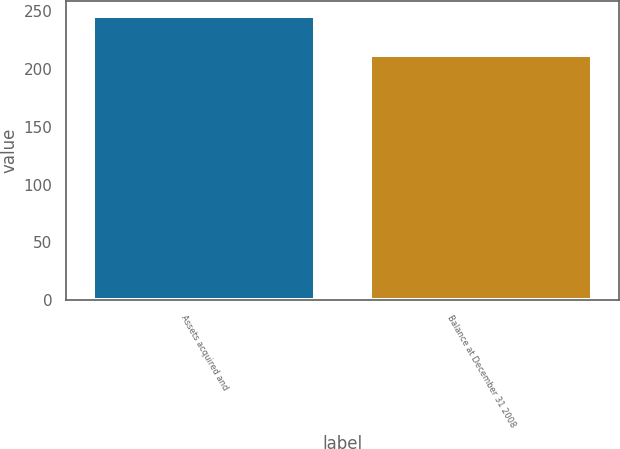Convert chart. <chart><loc_0><loc_0><loc_500><loc_500><bar_chart><fcel>Assets acquired and<fcel>Balance at December 31 2008<nl><fcel>246<fcel>212<nl></chart> 